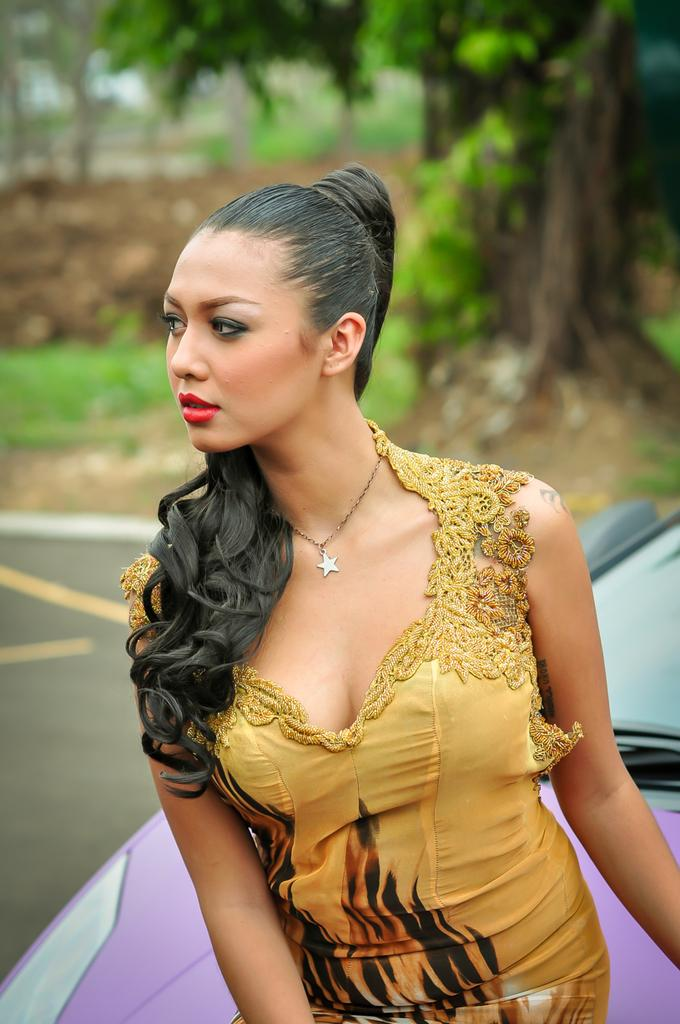Who is the main subject in the image? There is a lady in the image. What is the lady doing in the image? The lady is sitting on a car. What is the lady wearing in the image? The lady is wearing a gold color dress and a star pendant necklace. Where is the lady's father in the image? There is no mention of the lady's father in the image, so we cannot determine his location. 